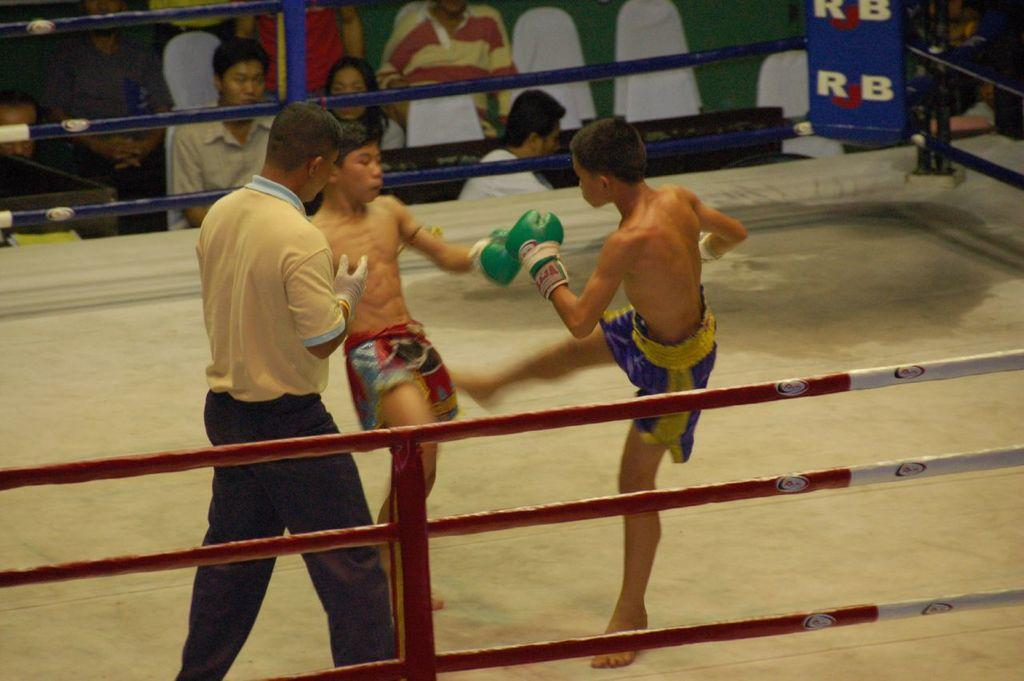<image>
Offer a succinct explanation of the picture presented. Two young kickboxers compete in a ring with RJB signs on it. 